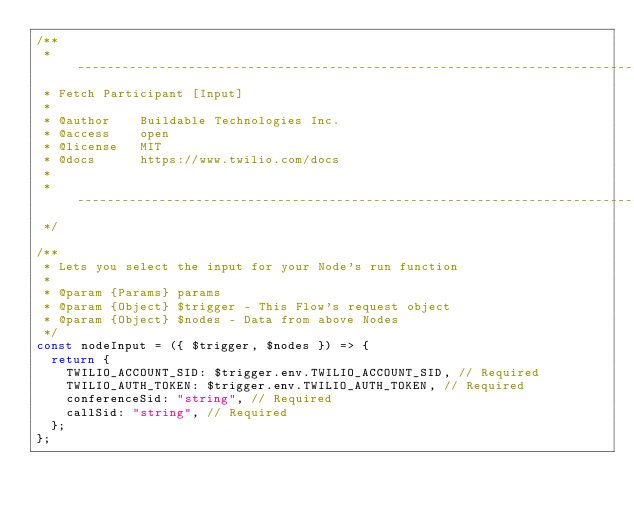Convert code to text. <code><loc_0><loc_0><loc_500><loc_500><_JavaScript_>/**
 * ----------------------------------------------------------------------------------------------------
 * Fetch Participant [Input]
 *
 * @author    Buildable Technologies Inc.
 * @access    open
 * @license   MIT
 * @docs      https://www.twilio.com/docs
 *
 * ----------------------------------------------------------------------------------------------------
 */

/**
 * Lets you select the input for your Node's run function
 *
 * @param {Params} params
 * @param {Object} $trigger - This Flow's request object
 * @param {Object} $nodes - Data from above Nodes
 */
const nodeInput = ({ $trigger, $nodes }) => {
  return {
    TWILIO_ACCOUNT_SID: $trigger.env.TWILIO_ACCOUNT_SID, // Required
    TWILIO_AUTH_TOKEN: $trigger.env.TWILIO_AUTH_TOKEN, // Required
    conferenceSid: "string", // Required
    callSid: "string", // Required
  };
};
</code> 